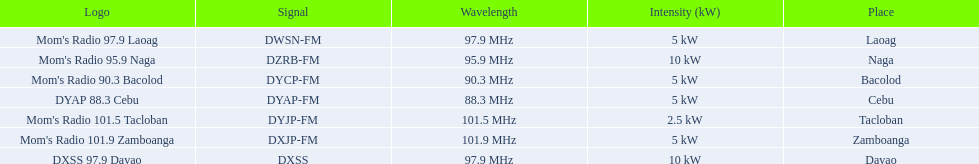Could you help me parse every detail presented in this table? {'header': ['Logo', 'Signal', 'Wavelength', 'Intensity (kW)', 'Place'], 'rows': [["Mom's Radio 97.9 Laoag", 'DWSN-FM', '97.9\xa0MHz', '5\xa0kW', 'Laoag'], ["Mom's Radio 95.9 Naga", 'DZRB-FM', '95.9\xa0MHz', '10\xa0kW', 'Naga'], ["Mom's Radio 90.3 Bacolod", 'DYCP-FM', '90.3\xa0MHz', '5\xa0kW', 'Bacolod'], ['DYAP 88.3 Cebu', 'DYAP-FM', '88.3\xa0MHz', '5\xa0kW', 'Cebu'], ["Mom's Radio 101.5 Tacloban", 'DYJP-FM', '101.5\xa0MHz', '2.5\xa0kW', 'Tacloban'], ["Mom's Radio 101.9 Zamboanga", 'DXJP-FM', '101.9\xa0MHz', '5\xa0kW', 'Zamboanga'], ['DXSS 97.9 Davao', 'DXSS', '97.9\xa0MHz', '10\xa0kW', 'Davao']]} What is the difference in kw between naga and bacolod radio? 5 kW. 